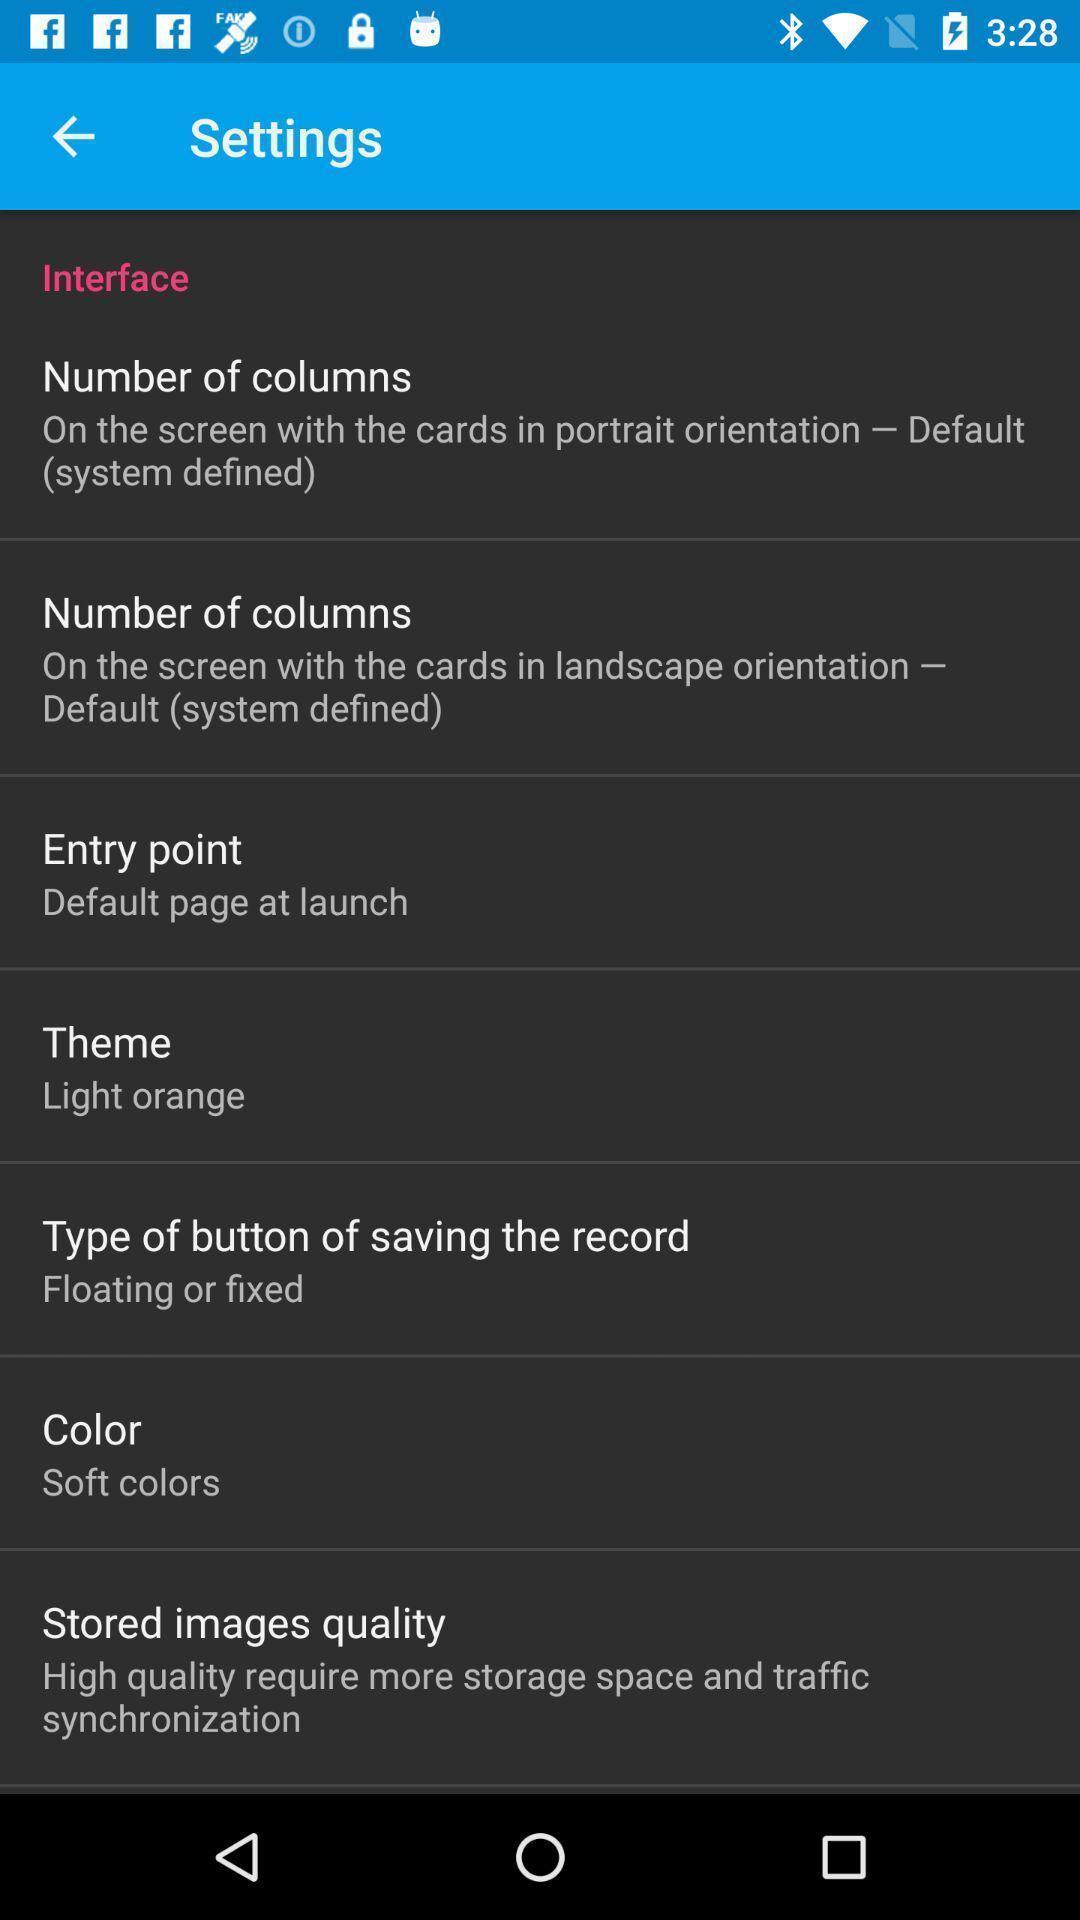Provide a detailed account of this screenshot. Screen shows about interface settings. 